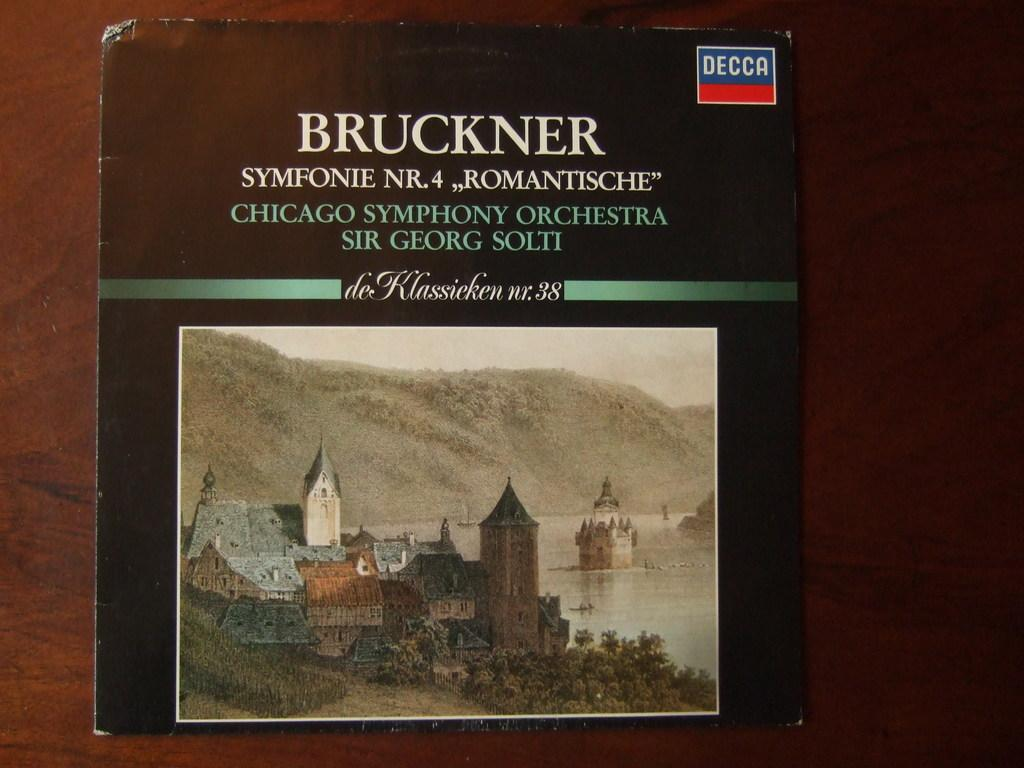<image>
Write a terse but informative summary of the picture. A record of Bruckner's Symfonie NR. 4 is on a wooden table. 